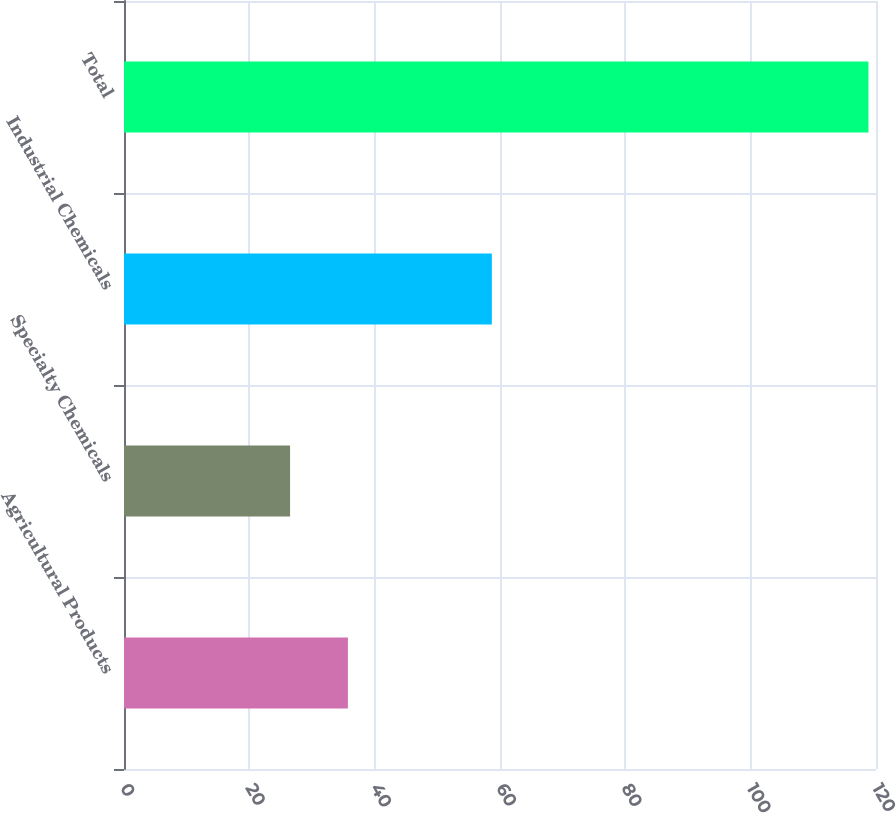Convert chart. <chart><loc_0><loc_0><loc_500><loc_500><bar_chart><fcel>Agricultural Products<fcel>Specialty Chemicals<fcel>Industrial Chemicals<fcel>Total<nl><fcel>35.73<fcel>26.5<fcel>58.7<fcel>118.8<nl></chart> 